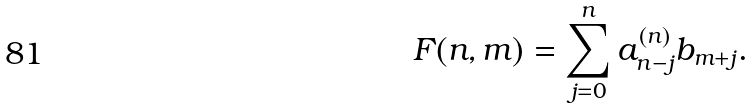<formula> <loc_0><loc_0><loc_500><loc_500>F ( n , m ) = \sum _ { j = 0 } ^ { n } a _ { n - j } ^ { ( n ) } b _ { m + j } .</formula> 